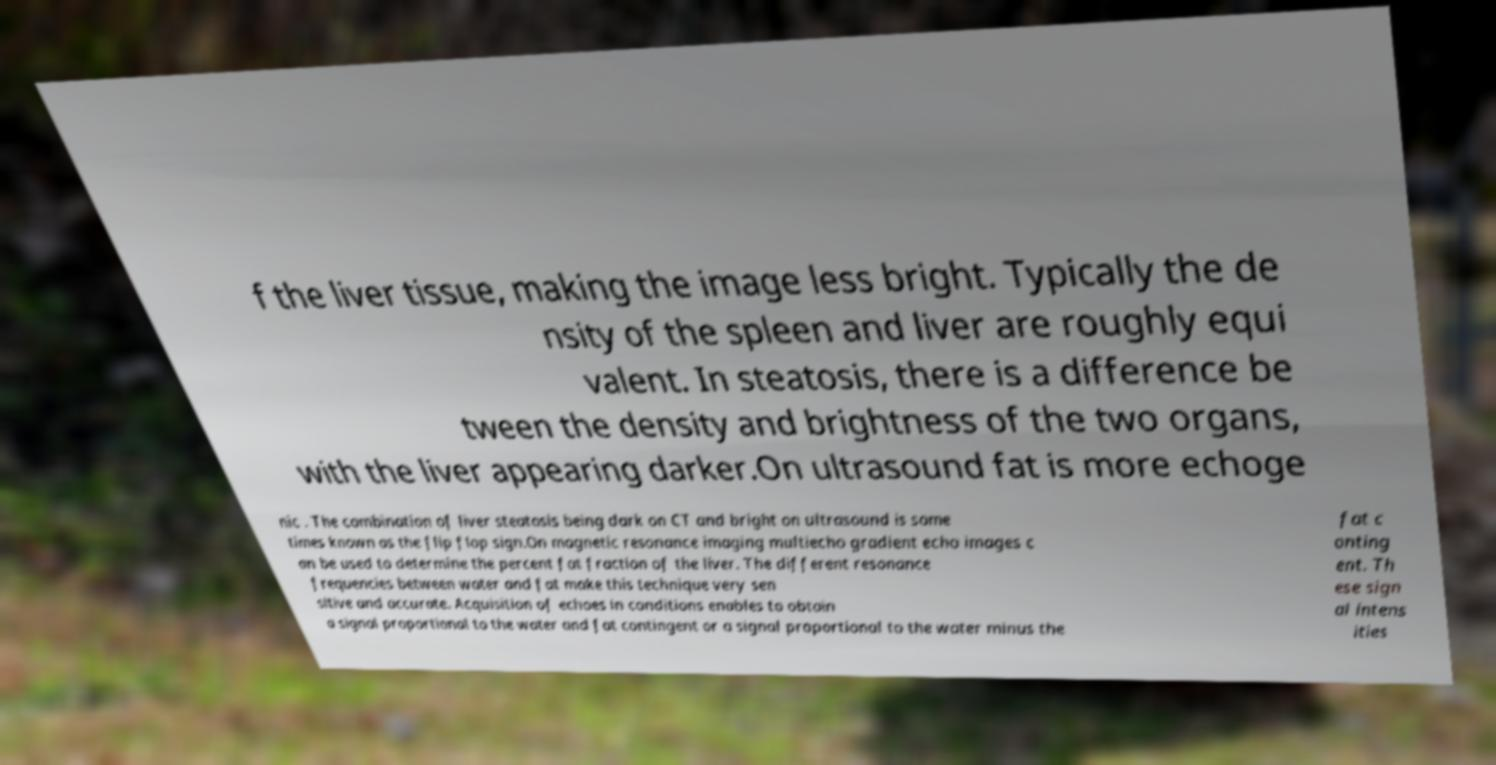Could you assist in decoding the text presented in this image and type it out clearly? f the liver tissue, making the image less bright. Typically the de nsity of the spleen and liver are roughly equi valent. In steatosis, there is a difference be tween the density and brightness of the two organs, with the liver appearing darker.On ultrasound fat is more echoge nic . The combination of liver steatosis being dark on CT and bright on ultrasound is some times known as the flip flop sign.On magnetic resonance imaging multiecho gradient echo images c an be used to determine the percent fat fraction of the liver. The different resonance frequencies between water and fat make this technique very sen sitive and accurate. Acquisition of echoes in conditions enables to obtain a signal proportional to the water and fat contingent or a signal proportional to the water minus the fat c onting ent. Th ese sign al intens ities 